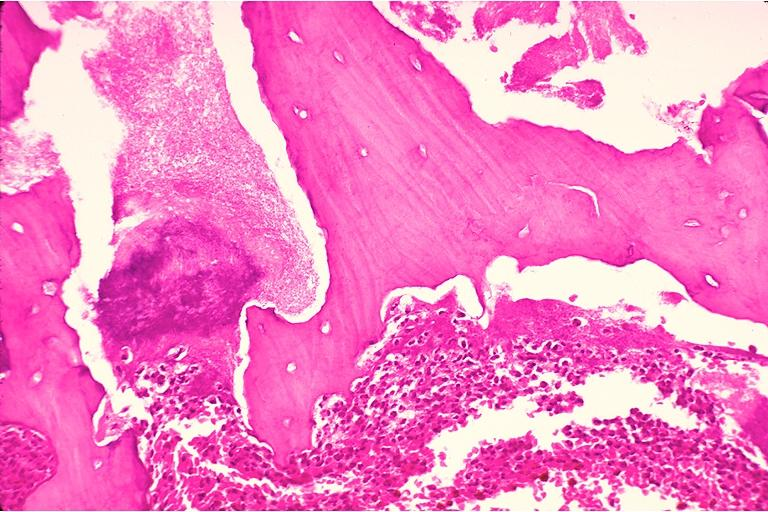what does this image show?
Answer the question using a single word or phrase. Chronic osteomyelitis 